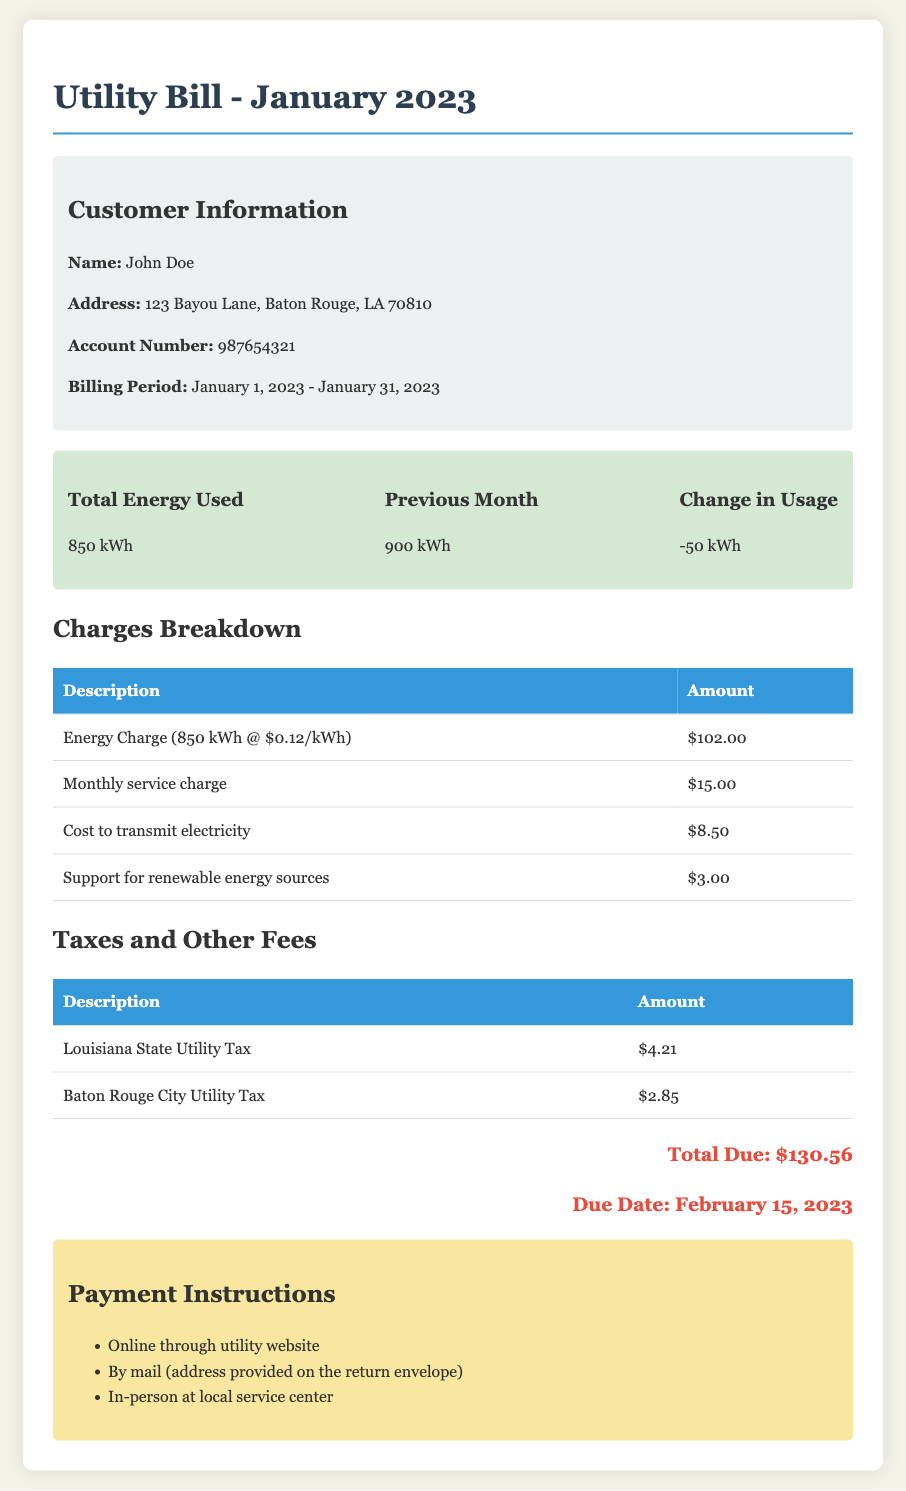What is the total energy used in January? The total energy used is stated in the usage summary section of the bill, which is 850 kWh.
Answer: 850 kWh What is the account number? The account number is listed in the customer information section of the document.
Answer: 987654321 How much is the monthly service charge? The monthly service charge is specified in the charges breakdown section of the document.
Answer: $15.00 What is the total due amount? The total due is provided in the total due section of the document.
Answer: $130.56 What is the due date for the payment? The due date is mentioned in the total due section of the bill.
Answer: February 15, 2023 What was the energy use in the previous month? The previous month's energy use is noted in the usage summary section of the bill.
Answer: 900 kWh How much was the Louisiana State Utility Tax? The Louisiana State Utility Tax is detailed in the taxes and other fees section of the document.
Answer: $4.21 What is the description of the first charge in the breakdown? The first charge is listed in the charges breakdown table.
Answer: Energy Charge (850 kWh @ $0.12/kWh) How can payments be made? The payment methods are provided in the payment instructions section of the bill.
Answer: Online, by mail, in-person How much is the cost to transmit electricity? The cost to transmit electricity is included in the charges breakdown section of the document.
Answer: $8.50 